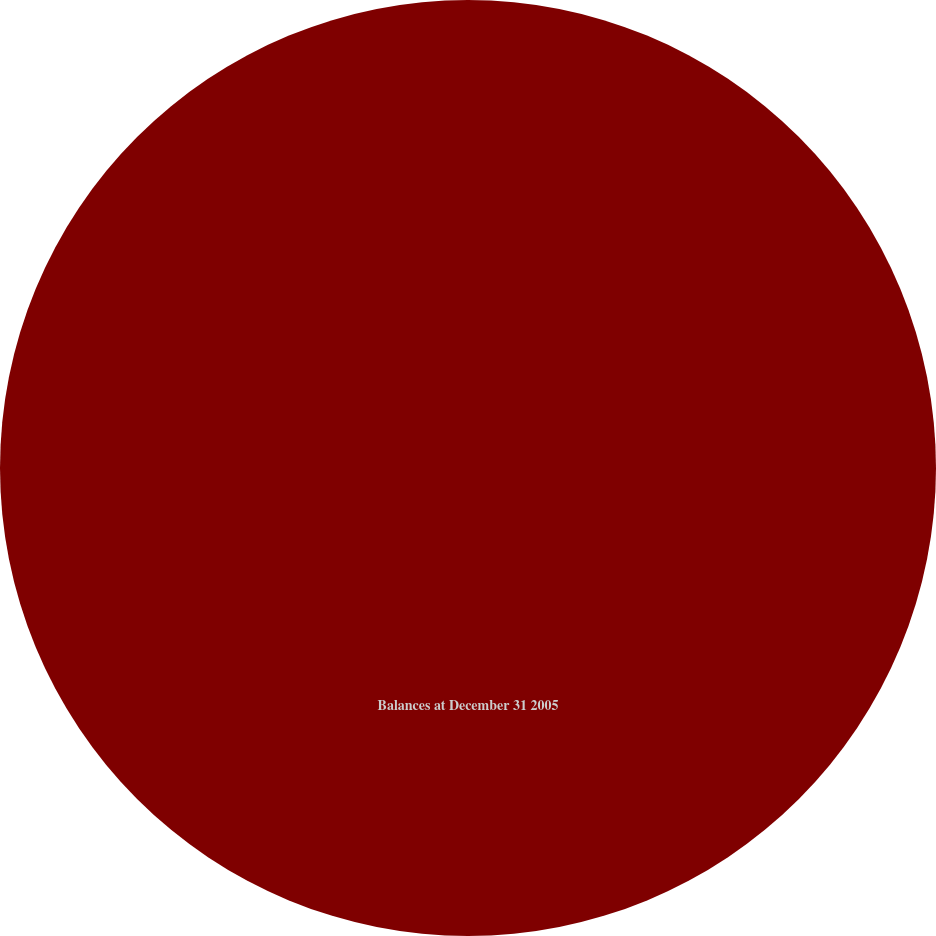Convert chart. <chart><loc_0><loc_0><loc_500><loc_500><pie_chart><fcel>Balances at December 31 2005<nl><fcel>100.0%<nl></chart> 